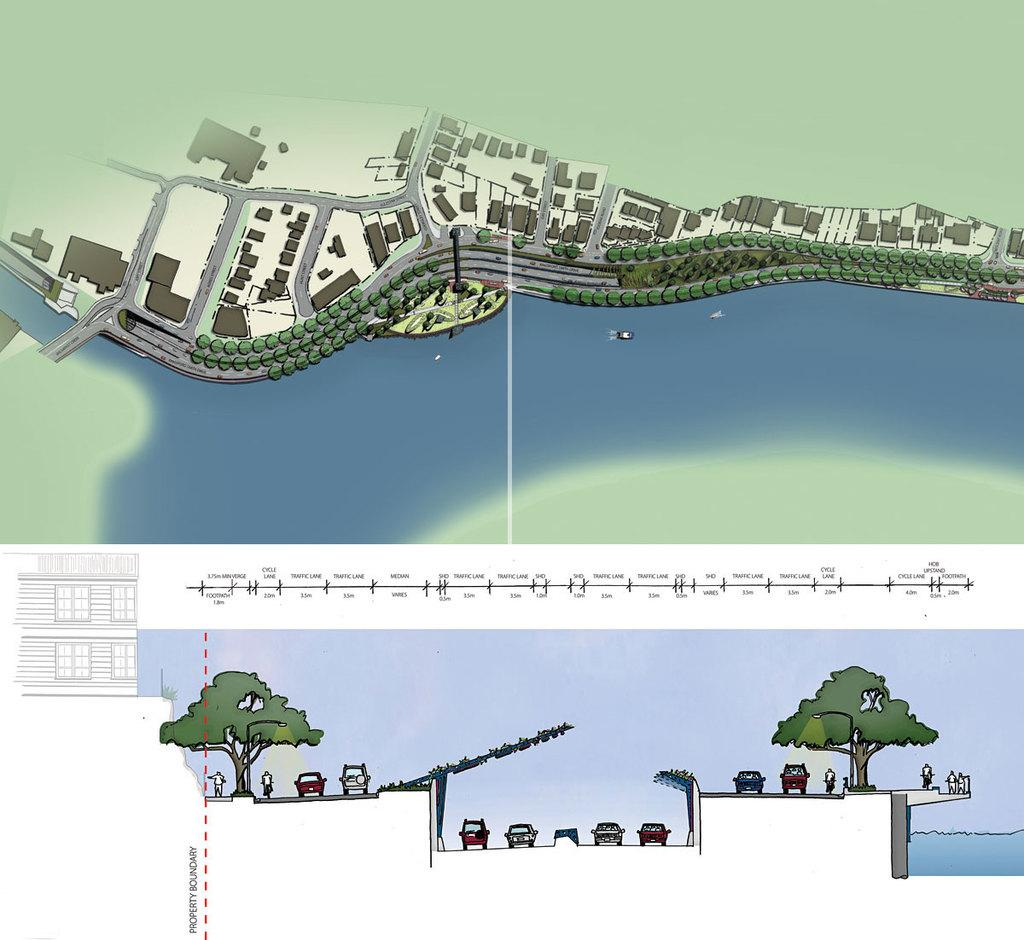What type of art is featured in the image? The image contains digital art. What natural elements can be seen in the digital art? There are trees visible in the digital art. What man-made elements can be seen in the digital art? There are vehicles, water, ground, and buildings visible in the digital art. How are the buildings depicted in the digital art? The buildings are depicted from an aerial view in the digital art. What type of teaching method is being demonstrated in the image? There is no teaching method present in the image; it features digital art with various elements. Can you see a skateboarder performing a trick in the image? There is no skateboarder or any indication of a skateboarding activity in the image. 